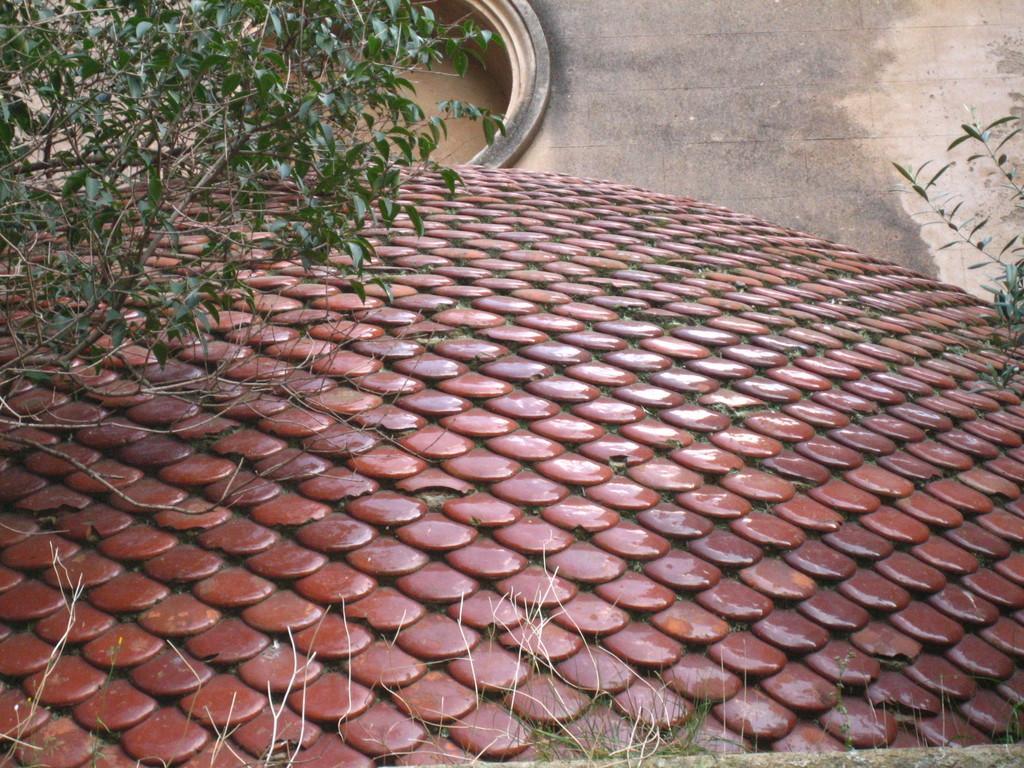In one or two sentences, can you explain what this image depicts? In this picture we can see the grass, design, plants, platform and an object. 